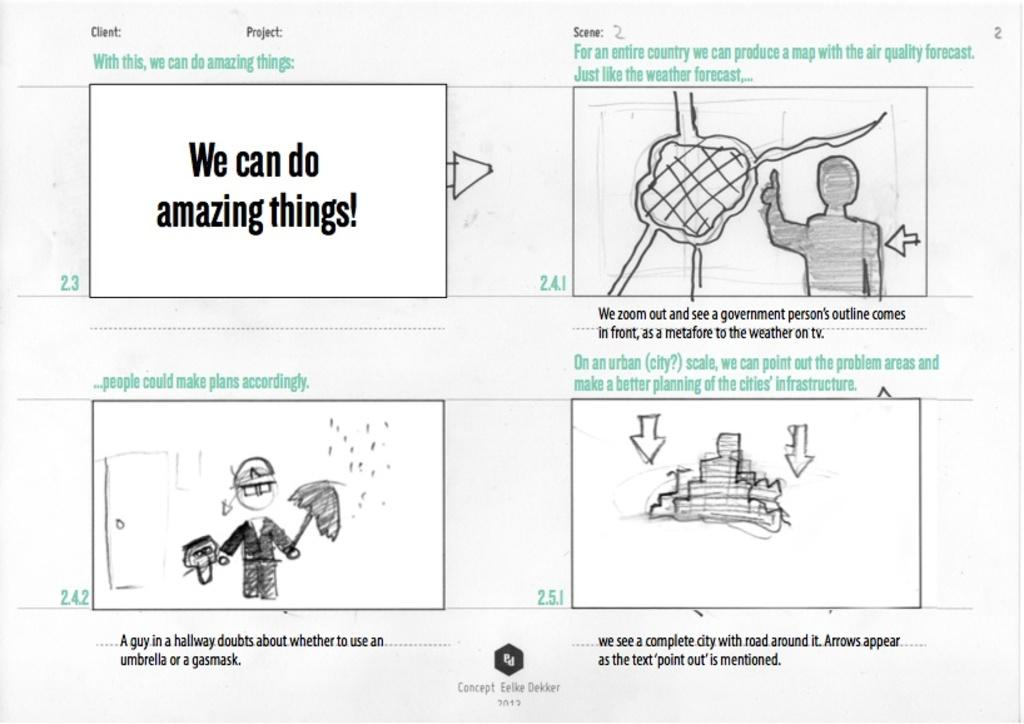What type of object is present in the image that is made of paper? There is a paper poster and a paper with a drawing in the image. What is depicted on the paper with a drawing? The facts do not specify what is depicted on the paper with a drawing. What can be found on the paper that is not a drawing? There is matter written on the paper in the image. How many children are playing with the ring in the image? There is no ring or children present in the image. 